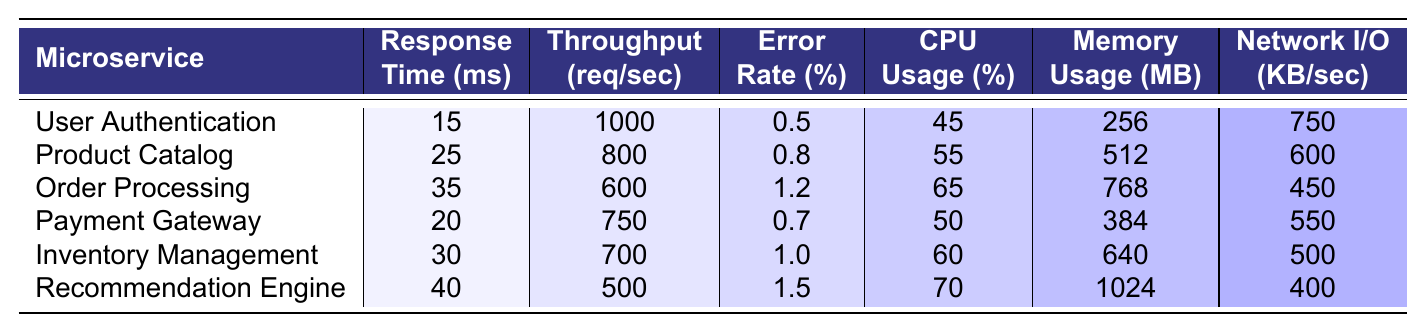What is the response time for the Payment Gateway microservice? The table lists the response times for each microservice, and for the Payment Gateway, it shows a value of 20 ms.
Answer: 20 ms Which microservice has the highest error rate? Looking at the Error Rate column, we see that the Recommendation Engine has the highest error rate at 1.5%.
Answer: Recommendation Engine What is the total CPU usage for all microservices? To find the total CPU usage, we add the CPU usage values for each microservice: 45 + 55 + 65 + 50 + 60 + 70 = 405.
Answer: 405% What is the average memory usage across all microservices? To calculate the average memory usage, we sum up the memory usage values (256 + 512 + 768 + 384 + 640 + 1024 = 2560) and divide by the number of microservices (6). The average is 2560 / 6 = 426.67.
Answer: 426.67 MB Is the throughput for Order Processing greater than that for Inventory Management? From the table, we see the throughput for Order Processing is 600 req/sec, while for Inventory Management it is 700 req/sec. Thus, Order Processing has lower throughput.
Answer: No Which microservice has the lowest network I/O? The Network I/O column indicates that the Recommendation Engine has the lowest value at 400 KB/sec.
Answer: Recommendation Engine What is the difference in response time between User Authentication and Order Processing? User Authentication has a response time of 15 ms and Order Processing has 35 ms. The difference is 35 - 15 = 20 ms.
Answer: 20 ms If we consider CPU usage, which microservice shows a result above the average usage of 57.5%? The average CPU usage is the total (405%) divided by 6, resulting in approximately 67.5%. From the table, the microservices with CPU usage above this average are Order Processing (65%), Inventory Management (60%), and Recommendation Engine (70%).
Answer: No, only Recommendation Engine What is the median throughput value amongst the microservices? The throughput values are 1000, 800, 600, 750, 700, 500. When arranged in ascending order (500, 600, 700, 750, 800, 1000), the median is the average of the two middle values (700 and 750), which is (700 + 750) / 2 = 725 req/sec.
Answer: 725 req/sec Do all microservices consume less than 1 GB of memory? The memory usage values are 256, 512, 768, 384, 640, and 1024 MB; since 1024 MB equals exactly 1 GB, at least one microservice exceeds this value.
Answer: No 